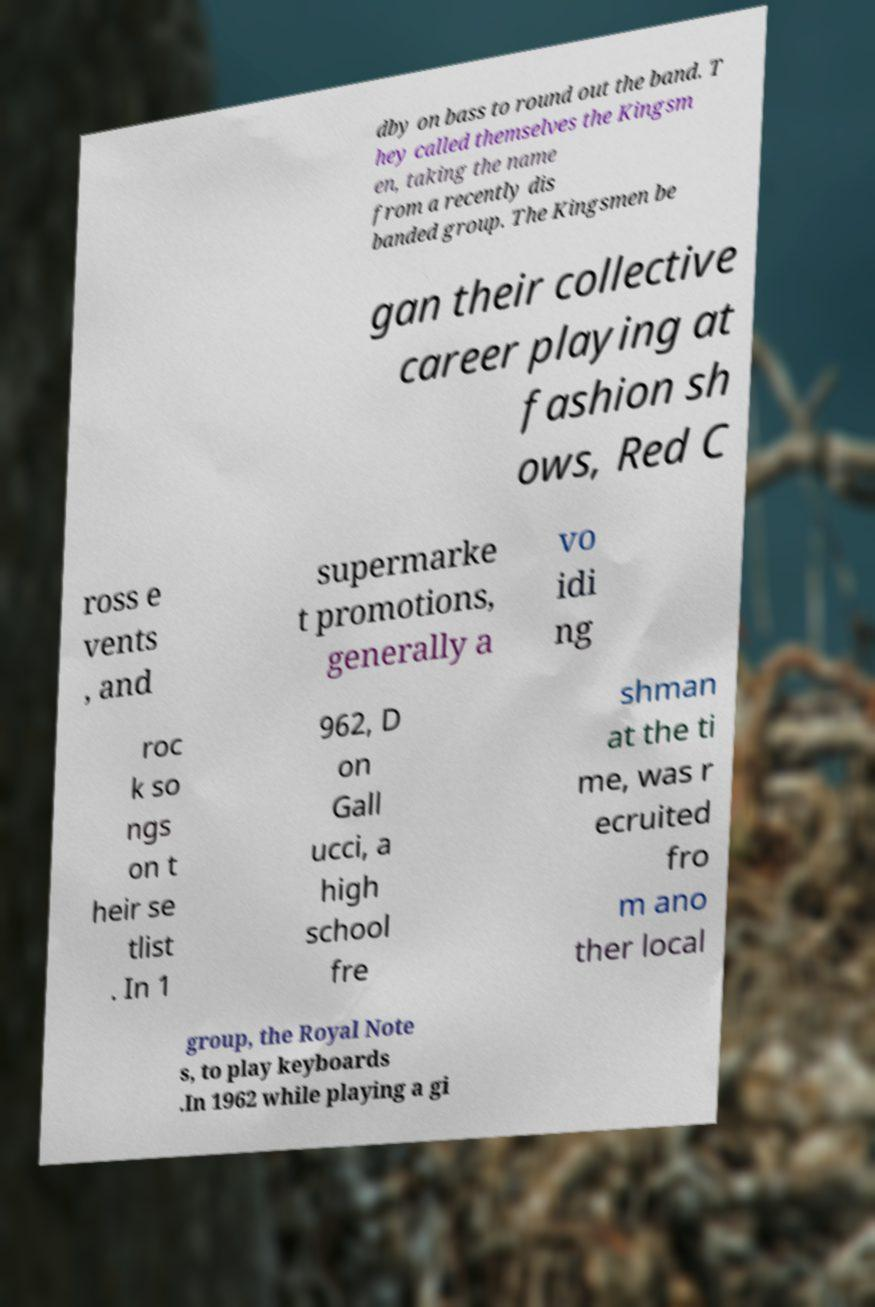What messages or text are displayed in this image? I need them in a readable, typed format. dby on bass to round out the band. T hey called themselves the Kingsm en, taking the name from a recently dis banded group. The Kingsmen be gan their collective career playing at fashion sh ows, Red C ross e vents , and supermarke t promotions, generally a vo idi ng roc k so ngs on t heir se tlist . In 1 962, D on Gall ucci, a high school fre shman at the ti me, was r ecruited fro m ano ther local group, the Royal Note s, to play keyboards .In 1962 while playing a gi 